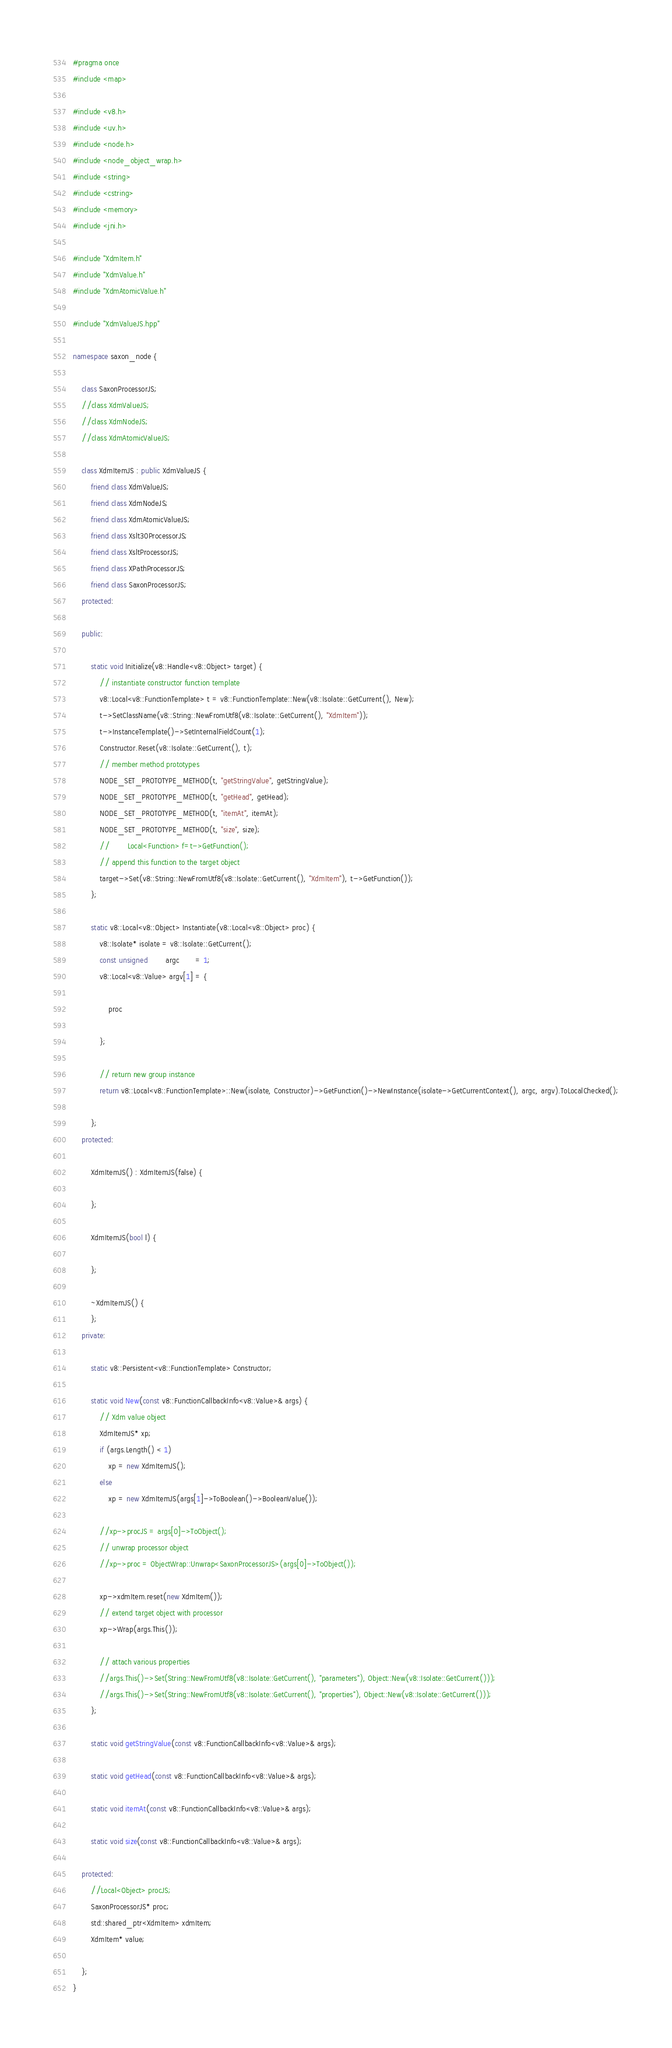<code> <loc_0><loc_0><loc_500><loc_500><_C++_>#pragma once
#include <map>

#include <v8.h>
#include <uv.h>
#include <node.h>
#include <node_object_wrap.h>
#include <string>
#include <cstring>
#include <memory>
#include <jni.h>

#include "XdmItem.h"
#include "XdmValue.h"
#include "XdmAtomicValue.h"

#include "XdmValueJS.hpp"

namespace saxon_node {

    class SaxonProcessorJS;
    //class XdmValueJS;
    //class XdmNodeJS;
    //class XdmAtomicValueJS;
    
    class XdmItemJS : public XdmValueJS {
        friend class XdmValueJS;
        friend class XdmNodeJS;
        friend class XdmAtomicValueJS;
        friend class Xslt30ProcessorJS;
        friend class XsltProcessorJS;
        friend class XPathProcessorJS;
        friend class SaxonProcessorJS;
    protected:

    public:

        static void Initialize(v8::Handle<v8::Object> target) {
            // instantiate constructor function template
            v8::Local<v8::FunctionTemplate> t = v8::FunctionTemplate::New(v8::Isolate::GetCurrent(), New);
            t->SetClassName(v8::String::NewFromUtf8(v8::Isolate::GetCurrent(), "XdmItem"));
            t->InstanceTemplate()->SetInternalFieldCount(1);
            Constructor.Reset(v8::Isolate::GetCurrent(), t);
            // member method prototypes
            NODE_SET_PROTOTYPE_METHOD(t, "getStringValue", getStringValue);
            NODE_SET_PROTOTYPE_METHOD(t, "getHead", getHead);
            NODE_SET_PROTOTYPE_METHOD(t, "itemAt", itemAt);
            NODE_SET_PROTOTYPE_METHOD(t, "size", size);
            //        Local<Function> f=t->GetFunction();
            // append this function to the target object
            target->Set(v8::String::NewFromUtf8(v8::Isolate::GetCurrent(), "XdmItem"), t->GetFunction());
        };

        static v8::Local<v8::Object> Instantiate(v8::Local<v8::Object> proc) {
            v8::Isolate* isolate = v8::Isolate::GetCurrent();
            const unsigned        argc       = 1;
            v8::Local<v8::Value> argv[1] = {

                proc

            };

            // return new group instance
            return v8::Local<v8::FunctionTemplate>::New(isolate, Constructor)->GetFunction()->NewInstance(isolate->GetCurrentContext(), argc, argv).ToLocalChecked();

        };
    protected:

        XdmItemJS() : XdmItemJS(false) {

        };

        XdmItemJS(bool l) {

        };

        ~XdmItemJS() {
        };
    private:

        static v8::Persistent<v8::FunctionTemplate> Constructor;

        static void New(const v8::FunctionCallbackInfo<v8::Value>& args) {
            // Xdm value object
            XdmItemJS* xp;
            if (args.Length() < 1)
                xp = new XdmItemJS();
            else
                xp = new XdmItemJS(args[1]->ToBoolean()->BooleanValue());

            //xp->procJS = args[0]->ToObject();
            // unwrap processor object
            //xp->proc = ObjectWrap::Unwrap<SaxonProcessorJS>(args[0]->ToObject());

            xp->xdmItem.reset(new XdmItem());
            // extend target object with processor
            xp->Wrap(args.This());

            // attach various properties
            //args.This()->Set(String::NewFromUtf8(v8::Isolate::GetCurrent(), "parameters"), Object::New(v8::Isolate::GetCurrent()));
            //args.This()->Set(String::NewFromUtf8(v8::Isolate::GetCurrent(), "properties"), Object::New(v8::Isolate::GetCurrent()));
        };

        static void getStringValue(const v8::FunctionCallbackInfo<v8::Value>& args);

        static void getHead(const v8::FunctionCallbackInfo<v8::Value>& args);

        static void itemAt(const v8::FunctionCallbackInfo<v8::Value>& args);

        static void size(const v8::FunctionCallbackInfo<v8::Value>& args);

    protected:
        //Local<Object> procJS;
        SaxonProcessorJS* proc;
        std::shared_ptr<XdmItem> xdmItem;
        XdmItem* value;

    };
}
</code> 